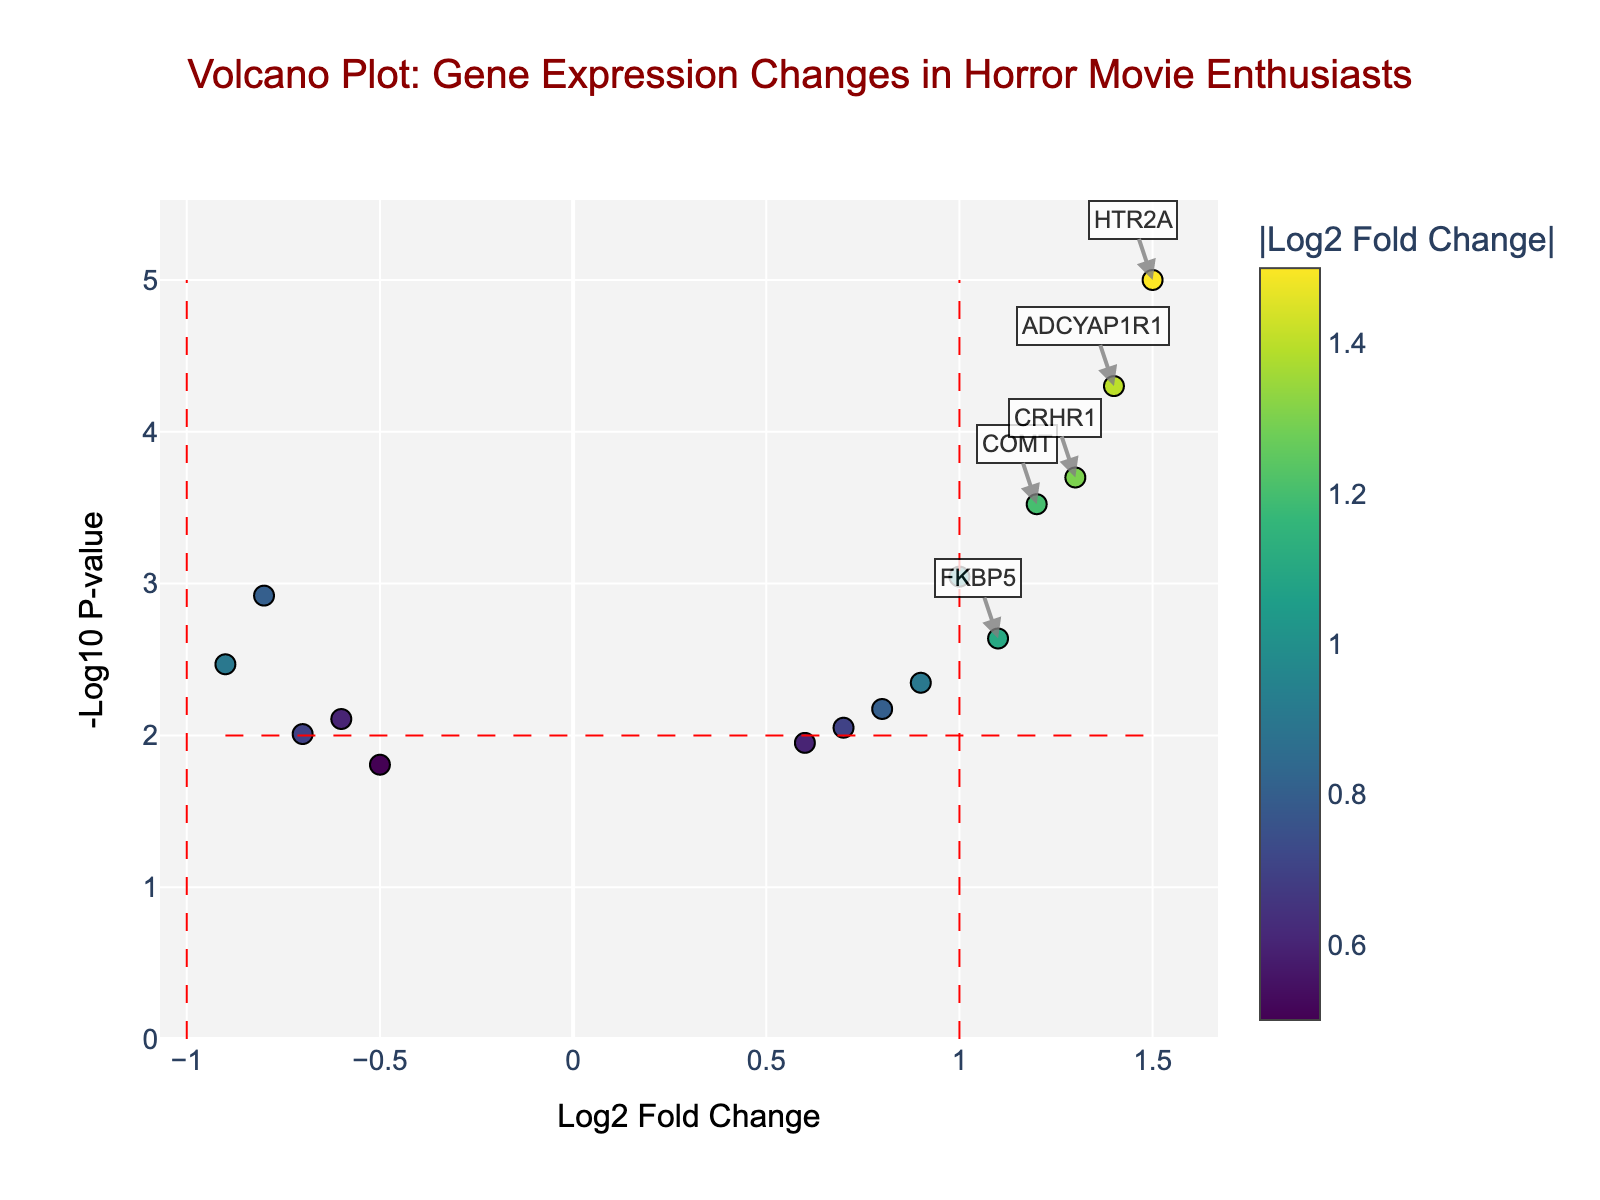What does the title of the plot indicate? The title of the plot is "Volcano Plot: Gene Expression Changes in Horror Movie Enthusiasts." This indicates that the plot shows gene expression changes in the amygdala of horror movie enthusiasts relative to a control group.
Answer: Gene Expression Changes in Horror Movie Enthusiasts Which gene has the highest log2 fold change? The log2 fold change represents how much the gene expression has changed. The highest log2 fold change can be identified by finding the data point with the highest x-value. In this case, HTR2A has the highest log2 fold change of 1.5.
Answer: HTR2A Which point in the plot represents the most statistically significant gene? The statistical significance is represented by the -log10(p-value) on the y-axis. The larger the -log10(p-value), the more statistically significant the gene. The highest -log10(p-value) is for HTR2A.
Answer: HTR2A How many genes show a statistically significant change in expression? To determine statistically significant changes, look for points with -log10(p-value) greater than 2 (since p-value < 0.01) and log2 fold change greater than 1 or less than -1. Visual inspection shows four points meeting these criteria: COMT, HTR2A, CRHR1, and ADCYAP1R1.
Answer: Four genes What is the log2 fold change and -log10(p-value) for COMT? The plot shows each gene's log2 fold change on the x-axis and -log10(p-value) on the y-axis. For COMT, log2 fold change is 1.2 and -log10(p-value) is 3.523. Checking this in the plot will confirm these values.
Answer: log2 fold change = 1.2, -log10(p-value) = 3.523 Which gene has the lowest p-value? The gene with the lowest p-value (highest -log10(p-value)) is the most statistically significant. HTR2A shows the highest -log10(p-value), making it the gene with the lowest p-value.
Answer: HTR2A What range of log2 fold change was used to add annotation lines on the plot? The annotation lines for log2 fold change are placed at threshold values of -1 and 1. These points represent the significant changes in gene expression.
Answer: -1 and 1 Are there any genes with a negative log2 fold change that are also statistically significant? Statistically significant genes have -log10(p-value) > 2. Look for points with a log2 fold change < -1 in this region. In this dataset, there are no such points.
Answer: No How does the expression change of NPY compare to MAOA? To compare, check the log2 fold change values of NPY and MAOA. MAOA has a log2 fold change of -0.8, and NPY has a log2 fold change of -0.9. Both have negative changes, but NPY has a larger magnitude of decrease.
Answer: NPY has a larger decrease 